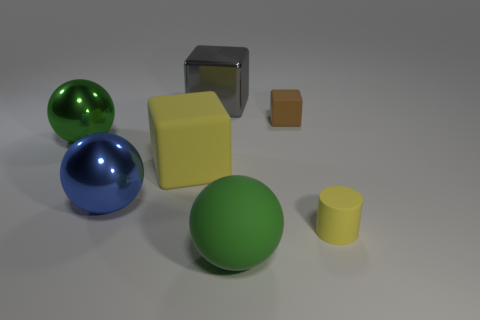What material is the small yellow cylinder?
Your answer should be compact. Rubber. What material is the green sphere that is in front of the rubber thing that is to the left of the metal thing that is behind the tiny brown cube made of?
Give a very brief answer. Rubber. There is a blue metallic thing that is the same size as the gray metallic cube; what is its shape?
Keep it short and to the point. Sphere. How many things are small matte cylinders or yellow objects behind the matte cylinder?
Your answer should be very brief. 2. Is the material of the yellow thing right of the big green rubber sphere the same as the yellow object behind the tiny cylinder?
Your answer should be very brief. Yes. The large object that is the same color as the big matte sphere is what shape?
Make the answer very short. Sphere. How many green things are either small matte cylinders or matte spheres?
Keep it short and to the point. 1. What is the size of the gray block?
Provide a short and direct response. Large. Is the number of large blue balls behind the tiny brown matte object greater than the number of large objects?
Offer a terse response. No. There is a blue metallic sphere; how many metallic things are behind it?
Provide a succinct answer. 2. 